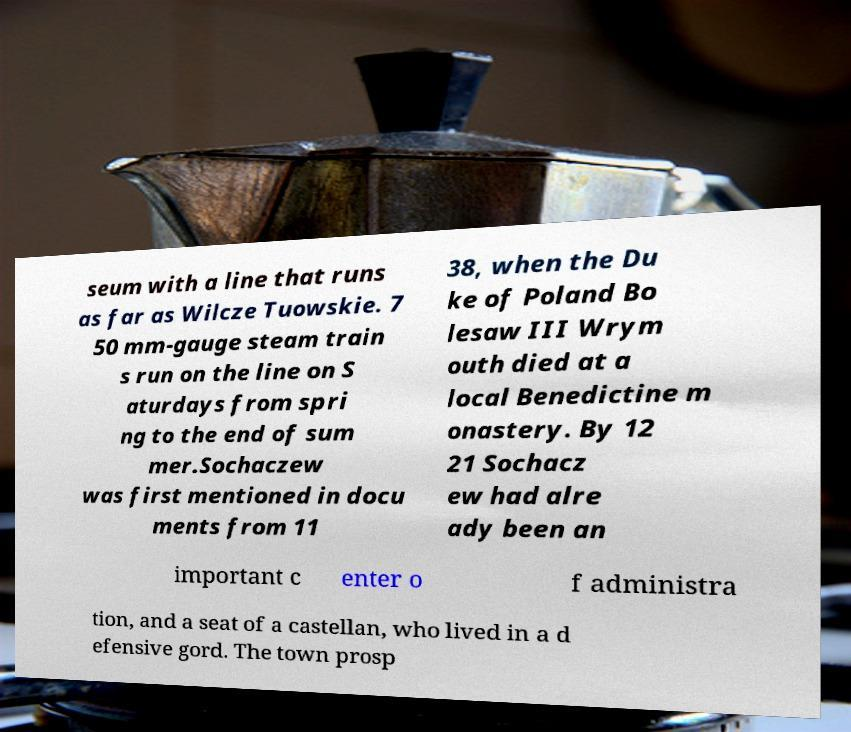Could you assist in decoding the text presented in this image and type it out clearly? seum with a line that runs as far as Wilcze Tuowskie. 7 50 mm-gauge steam train s run on the line on S aturdays from spri ng to the end of sum mer.Sochaczew was first mentioned in docu ments from 11 38, when the Du ke of Poland Bo lesaw III Wrym outh died at a local Benedictine m onastery. By 12 21 Sochacz ew had alre ady been an important c enter o f administra tion, and a seat of a castellan, who lived in a d efensive gord. The town prosp 